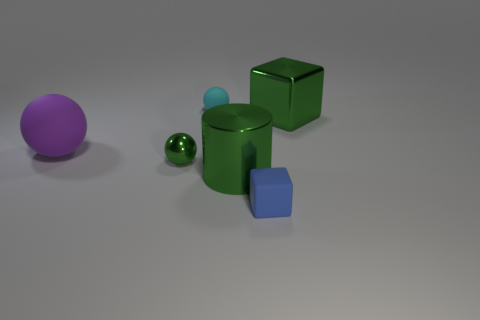What shape is the big shiny object that is the same color as the metal cylinder?
Offer a very short reply. Cube. There is a shiny object that is behind the green sphere; is it the same color as the small metal sphere?
Offer a terse response. Yes. How many matte blocks have the same size as the purple rubber ball?
Your response must be concise. 0. There is a large green thing that is made of the same material as the cylinder; what is its shape?
Ensure brevity in your answer.  Cube. Are there any big things that have the same color as the big cube?
Ensure brevity in your answer.  Yes. What material is the purple object?
Provide a succinct answer. Rubber. What number of things are either blue spheres or big purple rubber objects?
Provide a short and direct response. 1. How big is the cube that is in front of the large purple thing?
Your answer should be compact. Small. How many other objects are there of the same material as the purple ball?
Your answer should be very brief. 2. There is a tiny object behind the big purple ball; are there any green things that are to the right of it?
Provide a short and direct response. Yes. 